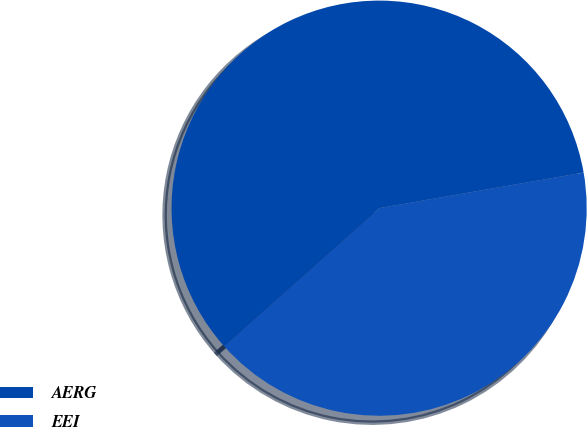<chart> <loc_0><loc_0><loc_500><loc_500><pie_chart><fcel>AERG<fcel>EEI<nl><fcel>58.82%<fcel>41.18%<nl></chart> 